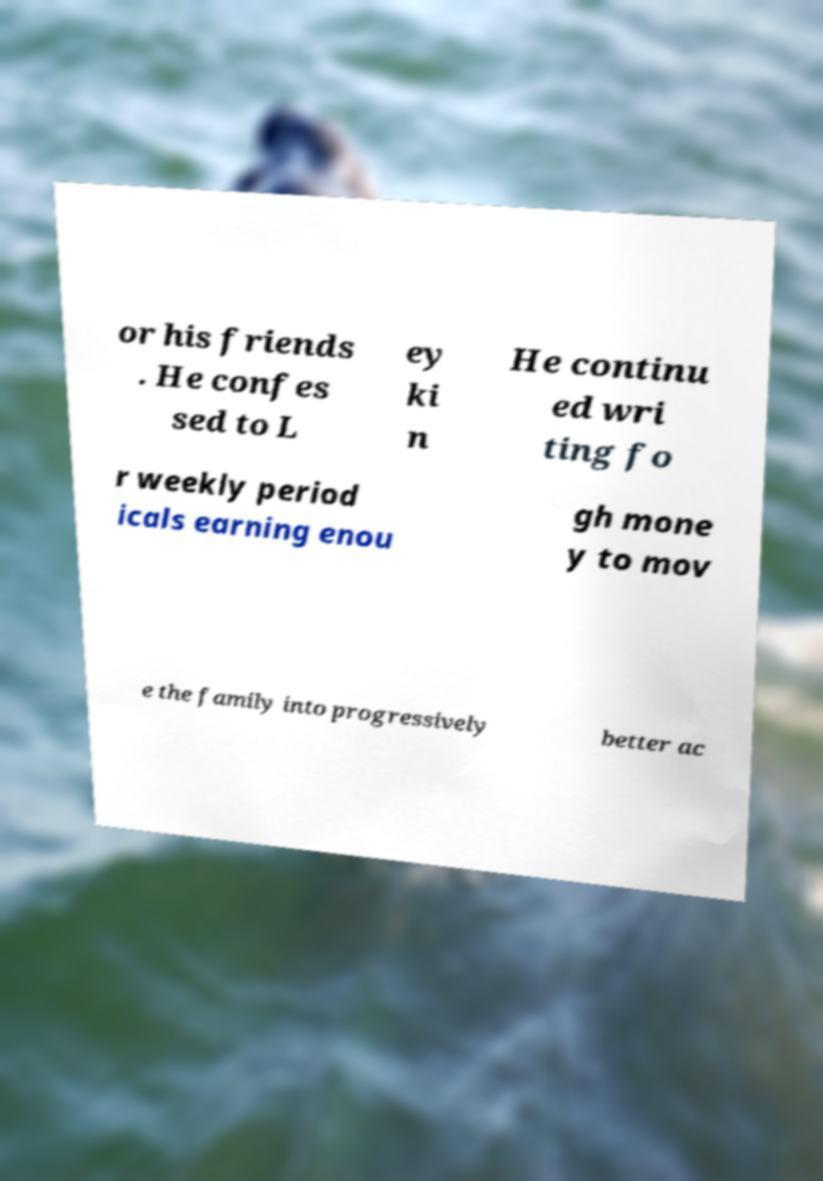Could you assist in decoding the text presented in this image and type it out clearly? or his friends . He confes sed to L ey ki n He continu ed wri ting fo r weekly period icals earning enou gh mone y to mov e the family into progressively better ac 